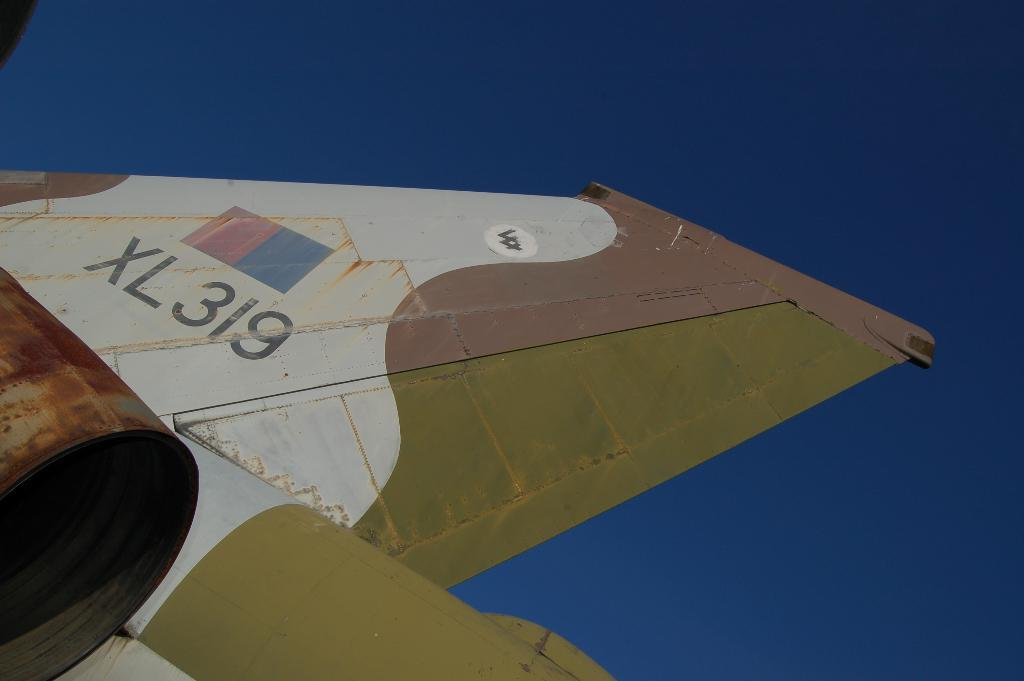<image>
Offer a succinct explanation of the picture presented. The wing of an airplane labeled XL 319. 